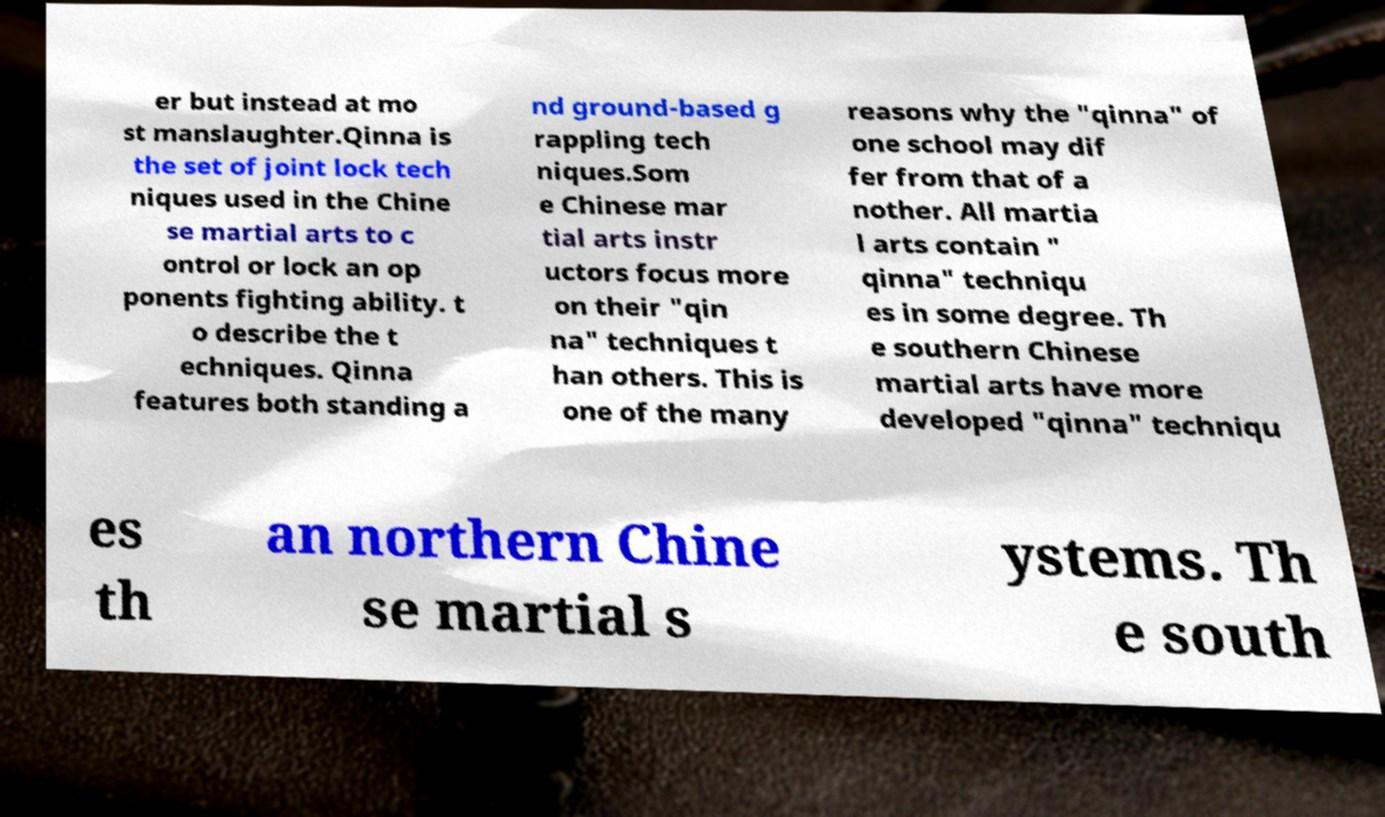What messages or text are displayed in this image? I need them in a readable, typed format. er but instead at mo st manslaughter.Qinna is the set of joint lock tech niques used in the Chine se martial arts to c ontrol or lock an op ponents fighting ability. t o describe the t echniques. Qinna features both standing a nd ground-based g rappling tech niques.Som e Chinese mar tial arts instr uctors focus more on their "qin na" techniques t han others. This is one of the many reasons why the "qinna" of one school may dif fer from that of a nother. All martia l arts contain " qinna" techniqu es in some degree. Th e southern Chinese martial arts have more developed "qinna" techniqu es th an northern Chine se martial s ystems. Th e south 